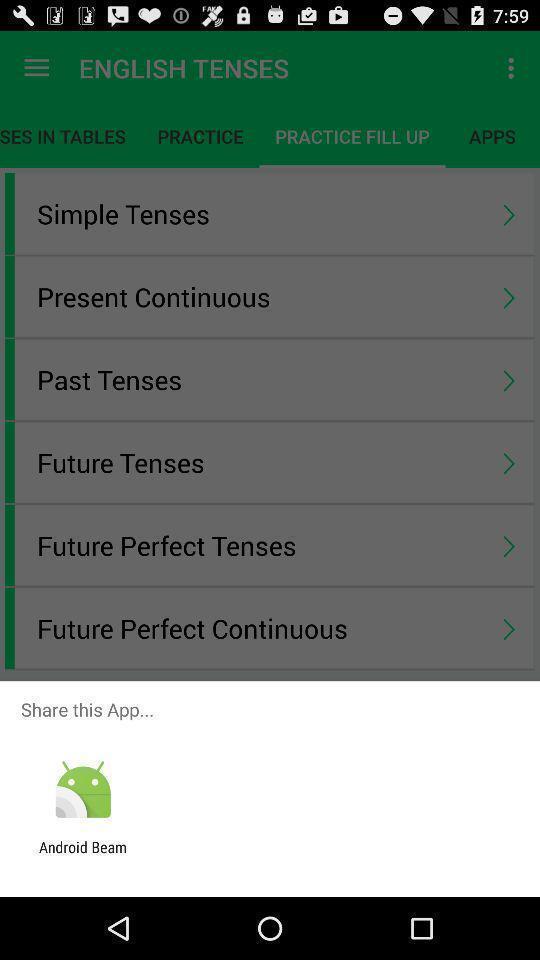Provide a textual representation of this image. Pop-up to share app via browser. 